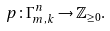<formula> <loc_0><loc_0><loc_500><loc_500>p \colon \Gamma _ { m , k } ^ { n } \rightarrow \mathbb { Z } _ { \geq 0 } .</formula> 